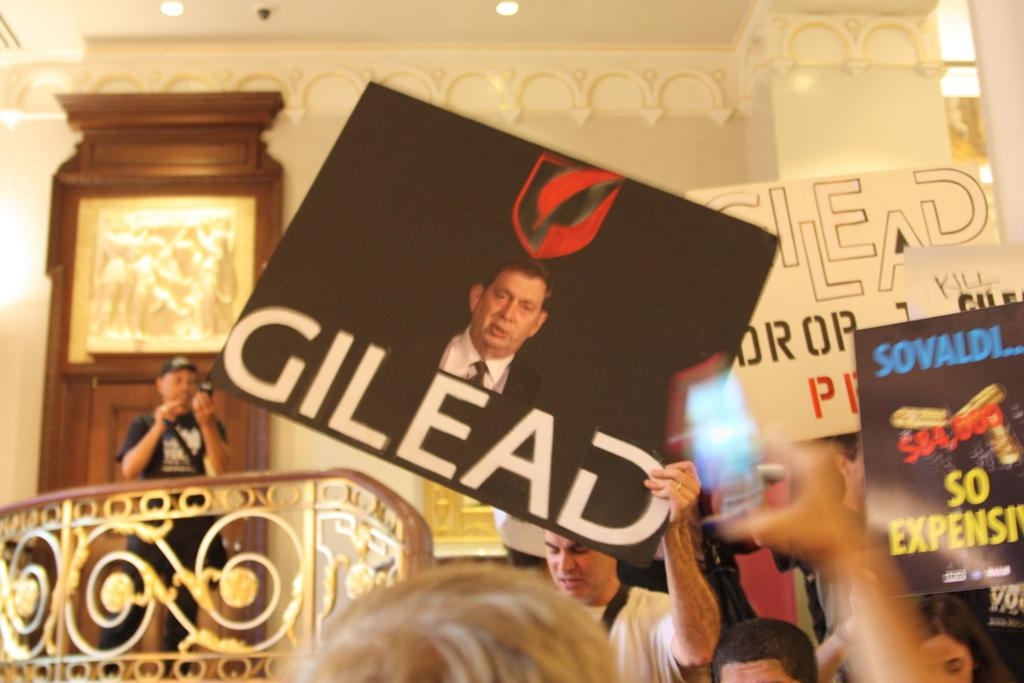What objects can be seen in the image that are used for displaying information? There are placards in the image that are used for displaying information. What can be observed about the people in the image? There are people in the image, but their specific actions or expressions are not mentioned in the provided facts. Where is the person holding a camera located in the image? The person holding a camera is on the left side of the image. What features can be seen on the left side of the image? There are railings and a door on the left side of the image. What type of lighting is present in the image? There are lights on the ceiling in the image. What type of war is depicted in the image? There is no depiction of a war in the image; it features placards, people, a person holding a camera, railings, a door, and lights on the ceiling. What level of detail can be seen on the placards in the image? The level of detail on the placards cannot be determined from the provided facts, as they do not mention the content or appearance of the placards. 